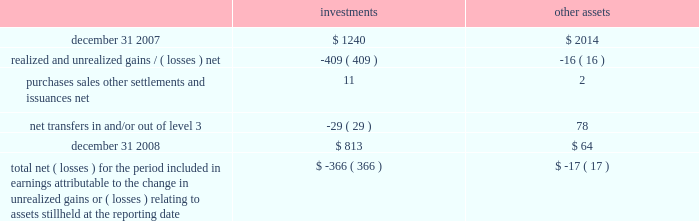A wholly-owned subsidiary of the company is a registered life insurance company that maintains separate account assets , representing segregated funds held for purposes of funding individual and group pension contracts , and equal and offsetting separate account liabilities .
At decem - ber 31 , 2008 and 2007 , the level 3 separate account assets were approximately $ 4 and $ 12 , respectively .
The changes in level 3 assets primarily relate to purchases , sales and gains/ ( losses ) .
The net investment income and net gains and losses attributable to separate account assets accrue directly to the contract owner and are not reported as non-operating income ( expense ) on the consolidated statements of income .
Level 3 assets , which includes equity method investments or consolidated investments of real estate funds , private equity funds and funds of private equity funds are valued based upon valuations received from internal as well as third party fund managers .
Fair valuations at the underlying funds are based on a combination of methods which may include third-party independent appraisals and discounted cash flow techniques .
Direct investments in private equity companies held by funds of private equity funds are valued based on an assessment of each under - lying investment , incorporating evaluation of additional significant third party financing , changes in valuations of comparable peer companies and the business environment of the companies , among other factors .
See note 2 for further detail on the fair value policies by the underlying funds .
Changes in level 3 assets measured at fair value on a recurring basis for the year ended december 31 , 2008 .
Total net ( losses ) for the period included in earnings attributable to the change in unrealized gains or ( losses ) relating to assets still held at the reporting date $ ( 366 ) $ ( 17 ) realized and unrealized gains and losses recorded for level 3 assets are reported in non-operating income ( expense ) on the consolidated statements of income .
Non-controlling interest expense is recorded for consoli- dated investments to reflect the portion of gains and losses not attributable to the company .
The company transfers assets in and/or out of level 3 as significant inputs , including performance attributes , used for the fair value measurement become observable .
Variable interest entities in the normal course of business , the company is the manager of various types of sponsored investment vehicles , including collateralized debt obligations and sponsored investment funds , that may be considered vies .
The company receives management fees or other incen- tive related fees for its services and may from time to time own equity or debt securities or enter into derivatives with the vehicles , each of which are considered variable inter- ests .
The company engages in these variable interests principally to address client needs through the launch of such investment vehicles .
The vies are primarily financed via capital contributed by equity and debt holders .
The company 2019s involvement in financing the operations of the vies is limited to its equity interests , unfunded capital commitments for certain sponsored investment funds and its capital support agreements for two enhanced cash funds .
The primary beneficiary of a vie is the party that absorbs a majority of the entity 2019s expected losses , receives a major - ity of the entity 2019s expected residual returns or both as a result of holding variable interests .
In order to determine whether the company is the primary beneficiary of a vie , management must make significant estimates and assumptions of probable future cash flows and assign probabilities to different cash flow scenarios .
Assumptions made in such analyses include , but are not limited to , market prices of securities , market interest rates , poten- tial credit defaults on individual securities or default rates on a portfolio of securities , gain realization , liquidity or marketability of certain securities , discount rates and the probability of certain other outcomes .
Vies in which blackrock is the primary beneficiary at december 31 , 2008 , the company was the primary beneficiary of three vies , which resulted in consolidation of three sponsored investment funds ( including two cash management funds and one private equity fund of funds ) .
Creditors of the vies do not have recourse to the credit of the company .
During 2008 , the company determined it became the primary beneficiary of two enhanced cash management funds as a result of concluding that under various cash 177528_txt_59_96:layout 1 3/26/09 10:32 pm page 73 .
What percent did the realized and unrealized losses effect the assets as of 2008? 
Computations: (409 / (409 + 813))
Answer: 0.3347. 